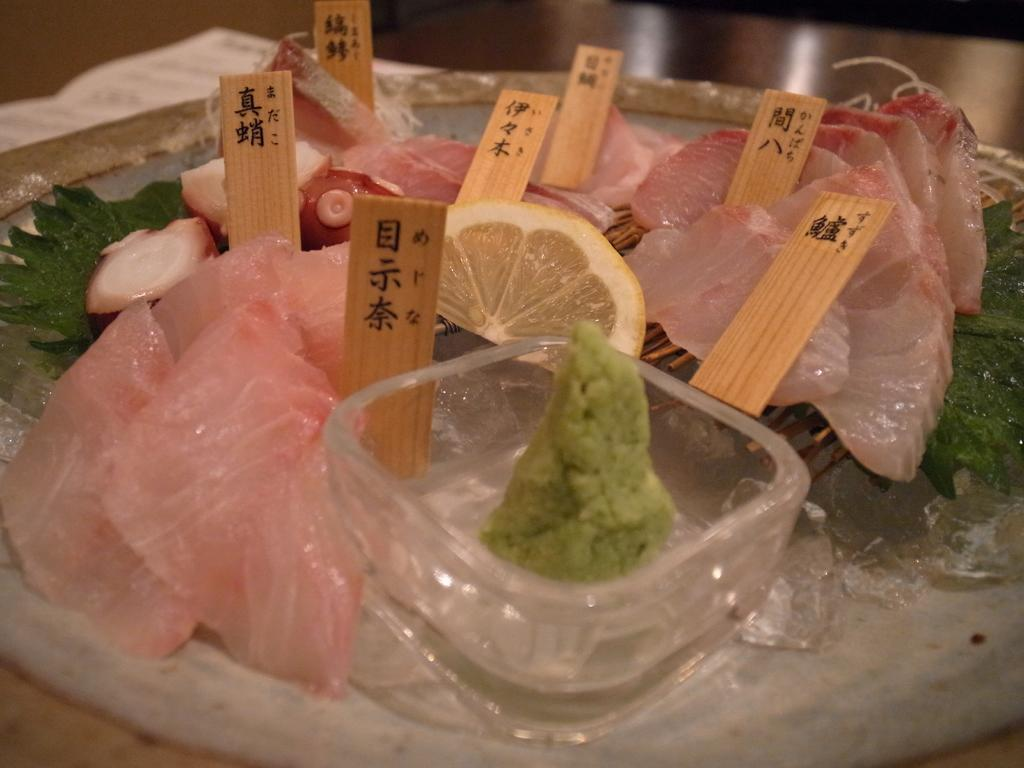What type of food item can be seen in the image? There is a food item on a surface in the image, but the specific type of food cannot be determined from the provided facts. What type of container is present in the image? There is a glass bowl in the image. What objects have text written on them in the image? There are sticks with text written on them in the image. What type of error can be seen in the image? There is no error present in the image. Can you describe the partner of the food item in the image? There is no partner mentioned or depicted in the image. 